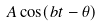Convert formula to latex. <formula><loc_0><loc_0><loc_500><loc_500>A \cos ( b t - \theta )</formula> 